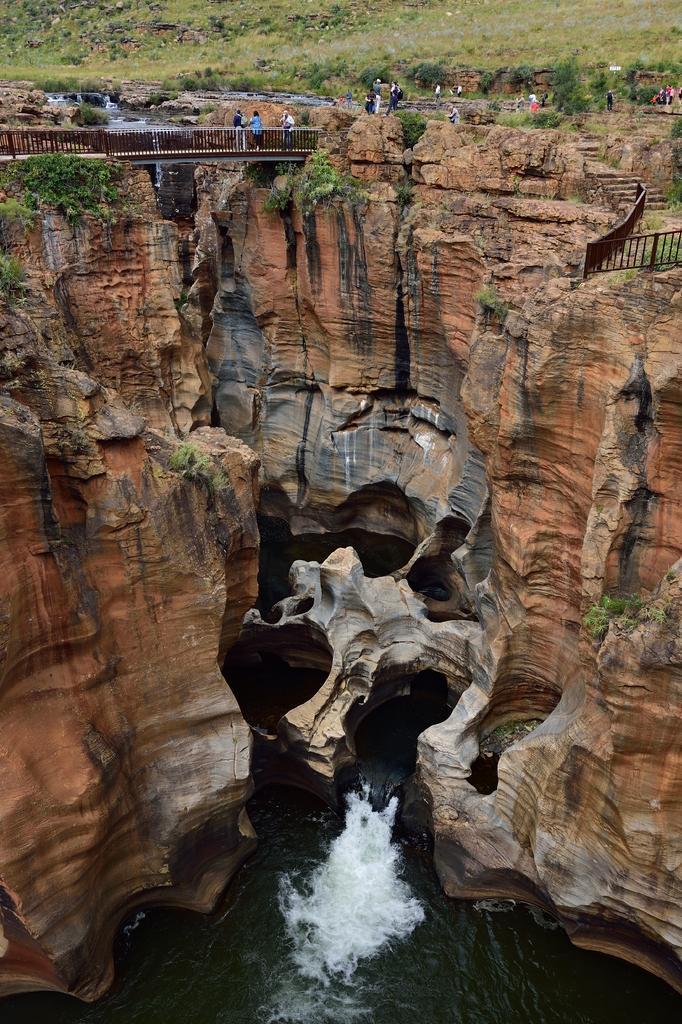Could you give a brief overview of what you see in this image? In this picture we can see the water, rocks, plants, fences, bridge, grass and a group of people. 